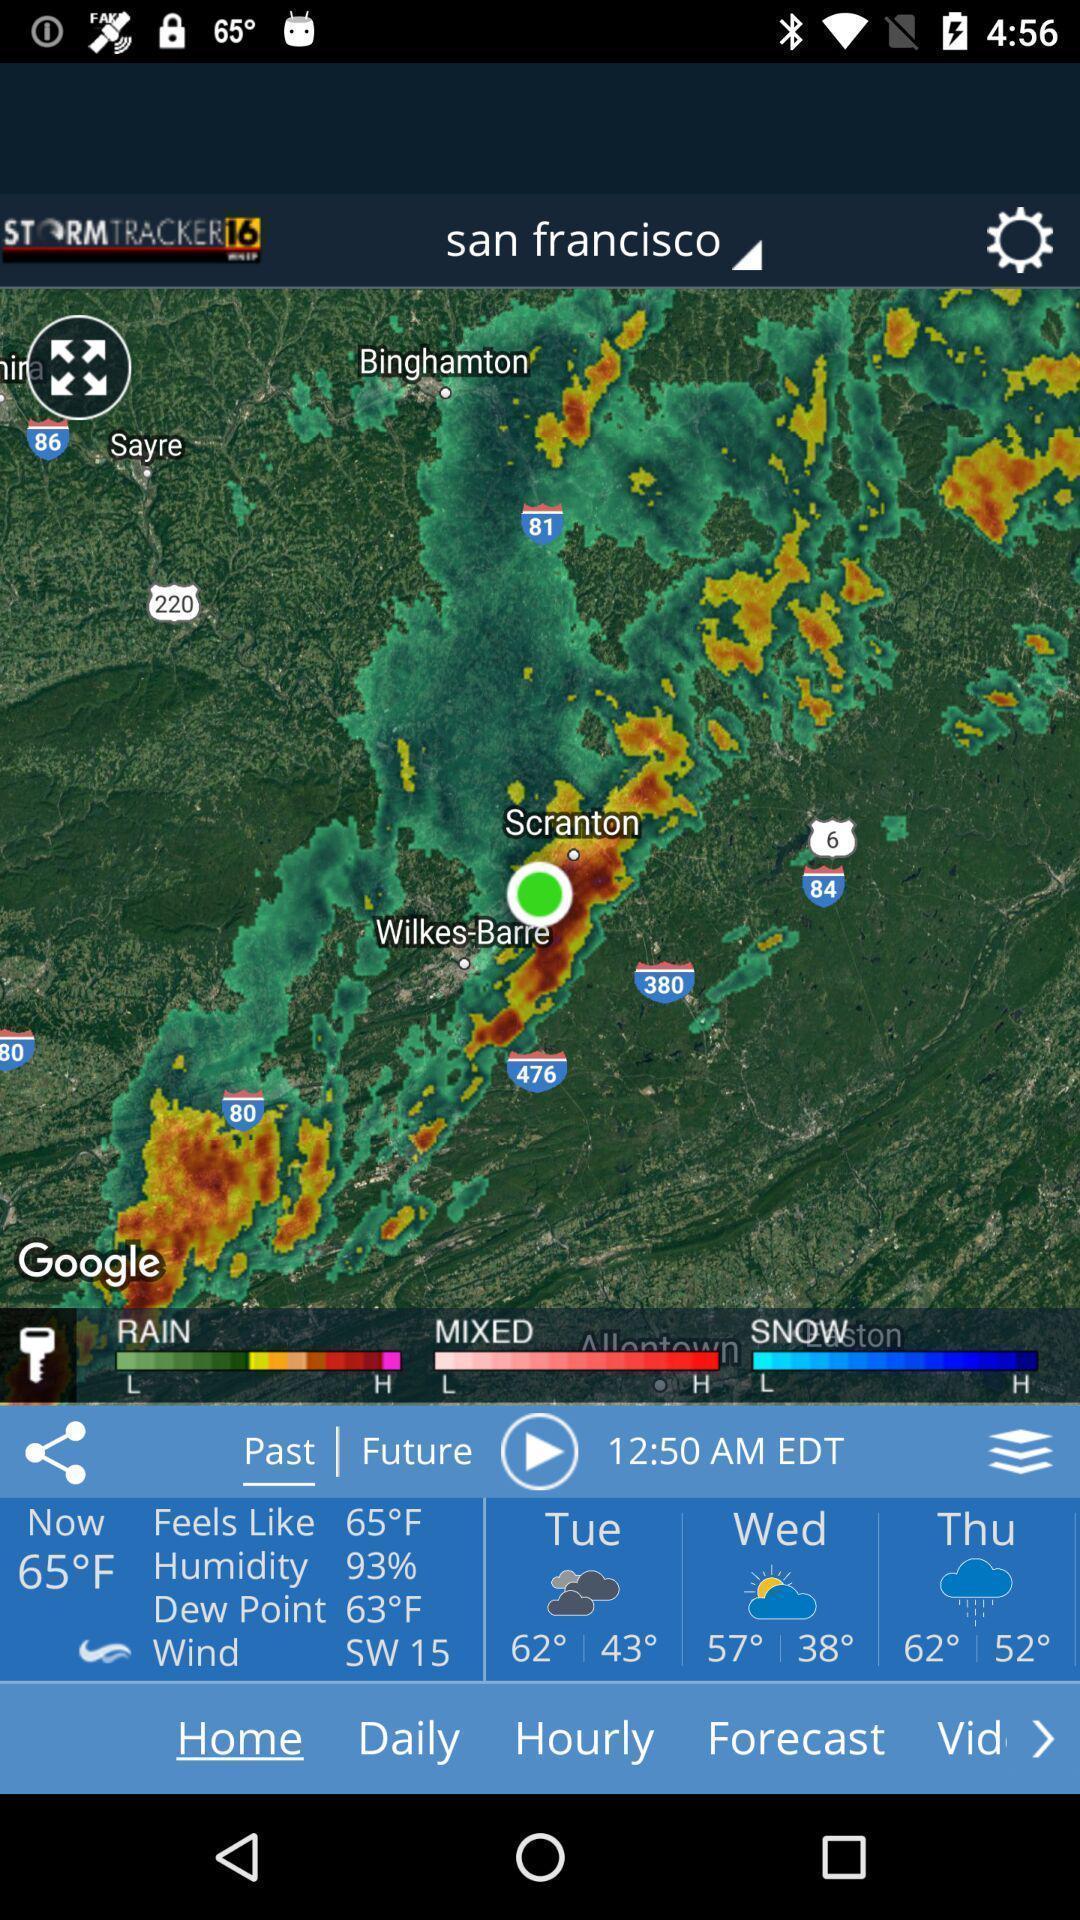What details can you identify in this image? Satellite view page displaying weather details of an weather app. 